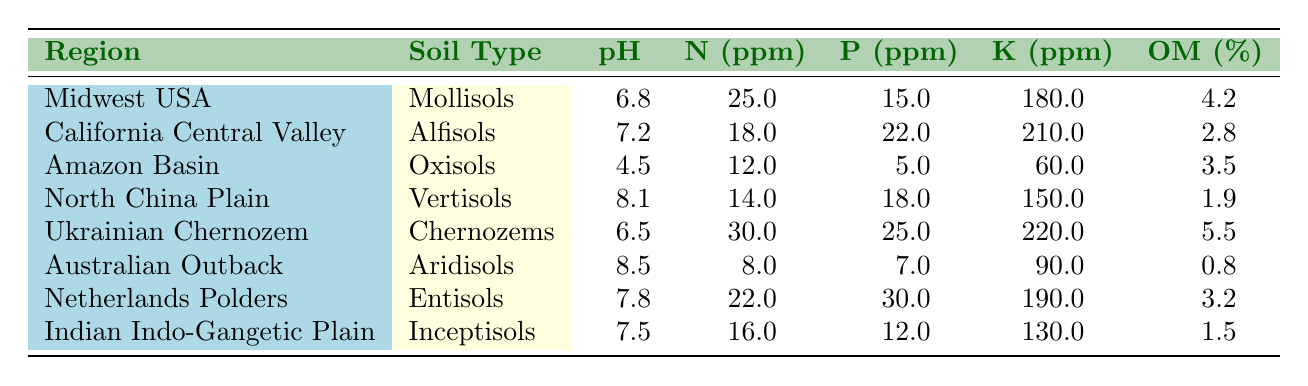What is the soil pH level in the Midwest USA? The table lists the pH level for the Midwest USA as 6.8.
Answer: 6.8 Which region has the highest potassium content in ppm? Comparing the potassium values in the table, the Ukrainian Chernozem has the highest value at 220 ppm.
Answer: 220 ppm Is the nitrogen content higher in the California Central Valley compared to the Amazon Basin? The nitrogen content for California Central Valley is 18 ppm and for the Amazon Basin is 12 ppm, so California Central Valley has higher nitrogen content.
Answer: Yes What is the average pH of all the regions listed? The pH values are 6.8, 7.2, 4.5, 8.1, 6.5, 8.5, 7.8, and 7.5. Adding these gives 6.8 + 7.2 + 4.5 + 8.1 + 6.5 + 8.5 + 7.8 + 7.5 = 56.9. Dividing by 8 regions gives an average of 56.9 / 8 = 7.1125.
Answer: 7.11 In which region is the organic matter content the lowest? The Australian Outback has the lowest organic matter content at 0.8%.
Answer: Australian Outback Is it true that the North China Plain has more phosphorus than the Indian Indo-Gangetic Plain? The North China Plain has 18 ppm of phosphorus, while the Indian Indo-Gangetic Plain has 12 ppm, confirming that the North China Plain has more phosphorus.
Answer: Yes Calculate the difference in nitrogen content between the Ukrainian Chernozem and the Australian Outback. The nitrogen for Ukrainian Chernozem is 30 ppm and for the Australian Outback is 8 ppm. The difference is 30 - 8 = 22 ppm.
Answer: 22 ppm Which soil type has the highest organic matter percentage? The Ukrainian Chernozem has the highest organic matter percentage at 5.5%.
Answer: 5.5% Determine the total potassium content (in ppm) across all regions. The potassium values are 180, 210, 60, 150, 220, 90, 190, and 130. Adding these gives 180 + 210 + 60 + 150 + 220 + 90 + 190 + 130 = 1,130 ppm total potassium.
Answer: 1,130 ppm Which region has the lowest soil pH, and what is that pH? The Amazon Basin has the lowest pH at 4.5.
Answer: Amazon Basin, 4.5 Is the phosphorus content in the Netherlands Polders greater than that in the California Central Valley? Netherlands Polders has 30 ppm of phosphorus and California Central Valley has 22 ppm. Thus, Netherlands Polders has greater phosphorus content.
Answer: Yes 